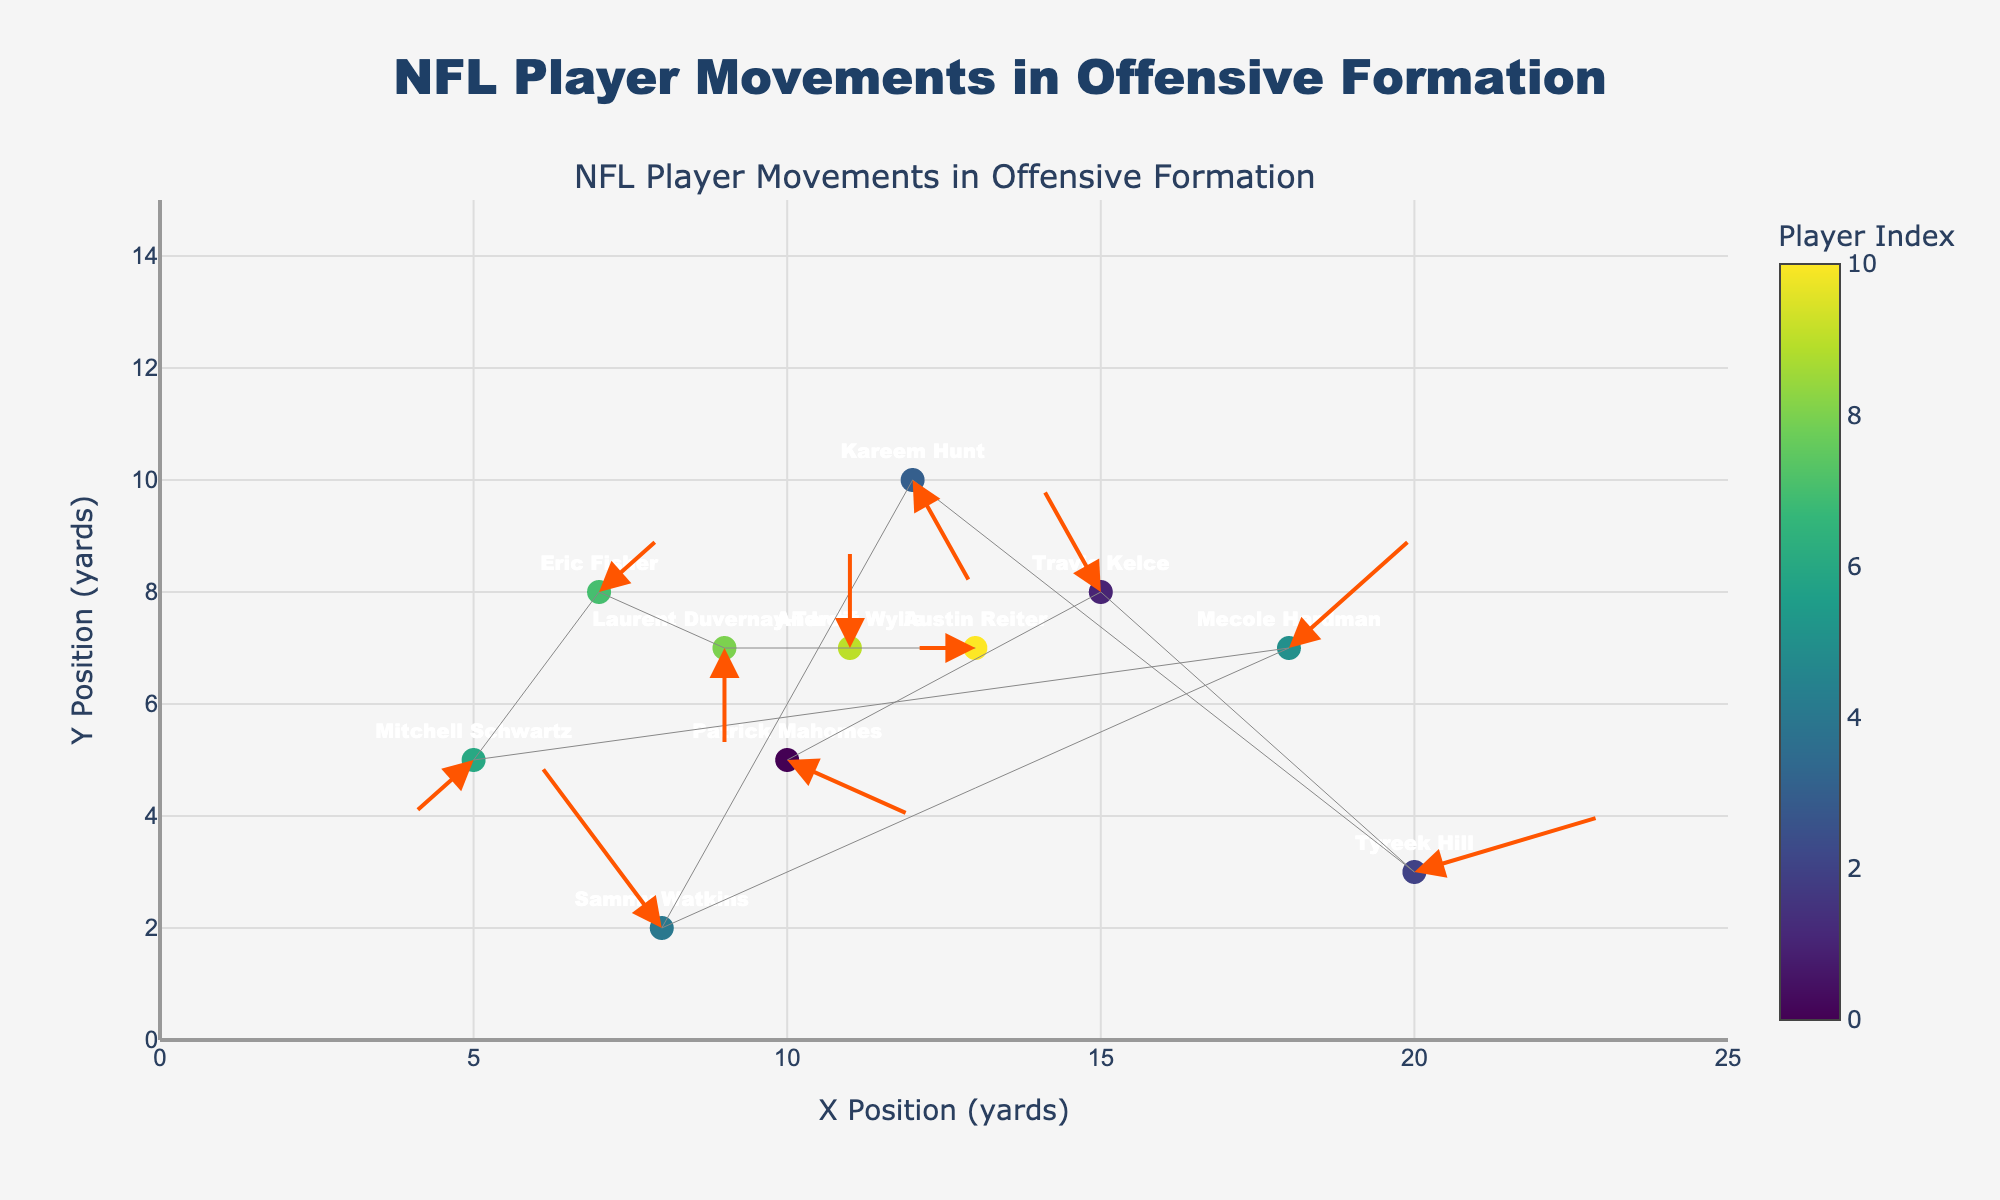What's the title of the plot? The title is directly visible at the top of the figure. It helps viewers quickly understand the context of the visualization.
Answer: NFL Player Movements in Offensive Formation How many players are represented in the plot? Each marker on the plot represents a player, and each player is labeled with their name. Count the names to get the total number of players.
Answer: 11 Which player has the biggest upward movement (positive y-direction)? Look at the arrows indicating the direction of movement. The length of the arrow in the y-direction represents the magnitude of movement.
Answer: Travis Kelce What is the initial position and movement vector of Patrick Mahomes? The initial position of Patrick Mahomes is marked by his starting coordinates (x, y), and his movement vector is given by (u, v).
Answer: (10, 5), (2, -1) Who is moving the fastest, based on the overall length of their movement vector? The speed can be approximated by the Euclidean distance formula sqrt(u^2 + v^2). Calculate for each player and compare.
Answer: Tyreek Hill Compare the movements of Patrick Mahomes and Kareem Hunt. Who is moving more in the x-direction? Look at the 'u' values for both players. Patrick Mahomes has a 'u' of 2, while Kareem Hunt has a 'u' of 1. Thus, Patrick Mahomes is moving more in the x-direction.
Answer: Patrick Mahomes How many players are moving in a negative y-direction? Observe the 'v' values for each player. Count how many have a negative value which indicates movement in the negative y-direction.
Answer: 4 Is there any player who does not move after their initial position? A player who does not move will have both 'u' and 'v' values equal to 0. Check if there is any such entry in the data.
Answer: No What's the average x-coordinate of all players' starting positions? Sum all x-coordinates and divide by the total number of players. Calculation: (10 + 15 + 20 + 12 + 8 + 18 + 5 + 7 + 9 + 11 + 13) / 11 = 11.45
Answer: 11.45 Regarding Tyreek Hill, what's the sum of his x and y movements? For Tyreek Hill, sum his movement components in the x and y directions. Add 'u' and 'v' (3 + 1).
Answer: 4 